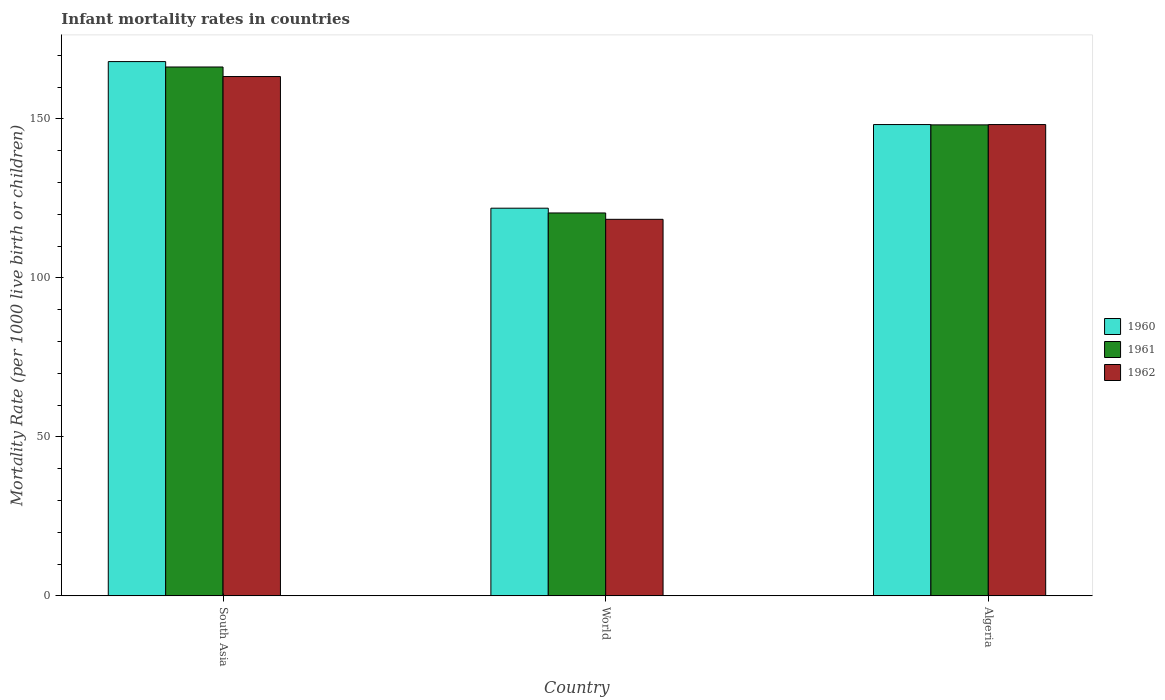How many different coloured bars are there?
Keep it short and to the point. 3. Are the number of bars per tick equal to the number of legend labels?
Your answer should be very brief. Yes. Are the number of bars on each tick of the X-axis equal?
Ensure brevity in your answer.  Yes. How many bars are there on the 2nd tick from the left?
Your answer should be compact. 3. How many bars are there on the 2nd tick from the right?
Give a very brief answer. 3. What is the label of the 2nd group of bars from the left?
Provide a short and direct response. World. What is the infant mortality rate in 1961 in Algeria?
Provide a short and direct response. 148.1. Across all countries, what is the maximum infant mortality rate in 1962?
Your response must be concise. 163.3. Across all countries, what is the minimum infant mortality rate in 1962?
Provide a short and direct response. 118.4. In which country was the infant mortality rate in 1962 maximum?
Offer a very short reply. South Asia. What is the total infant mortality rate in 1962 in the graph?
Provide a succinct answer. 429.9. What is the difference between the infant mortality rate in 1962 in Algeria and that in South Asia?
Provide a short and direct response. -15.1. What is the difference between the infant mortality rate in 1960 in World and the infant mortality rate in 1961 in Algeria?
Ensure brevity in your answer.  -26.2. What is the average infant mortality rate in 1960 per country?
Your answer should be compact. 146.03. In how many countries, is the infant mortality rate in 1962 greater than 100?
Offer a terse response. 3. What is the ratio of the infant mortality rate in 1960 in Algeria to that in South Asia?
Ensure brevity in your answer.  0.88. Is the infant mortality rate in 1961 in Algeria less than that in South Asia?
Give a very brief answer. Yes. Is the difference between the infant mortality rate in 1961 in Algeria and World greater than the difference between the infant mortality rate in 1960 in Algeria and World?
Offer a very short reply. Yes. What is the difference between the highest and the second highest infant mortality rate in 1962?
Your answer should be compact. 15.1. What is the difference between the highest and the lowest infant mortality rate in 1960?
Make the answer very short. 46.1. In how many countries, is the infant mortality rate in 1961 greater than the average infant mortality rate in 1961 taken over all countries?
Your response must be concise. 2. What does the 3rd bar from the right in South Asia represents?
Keep it short and to the point. 1960. Are all the bars in the graph horizontal?
Provide a short and direct response. No. How many countries are there in the graph?
Your response must be concise. 3. What is the difference between two consecutive major ticks on the Y-axis?
Ensure brevity in your answer.  50. Does the graph contain any zero values?
Your answer should be compact. No. Does the graph contain grids?
Provide a short and direct response. No. Where does the legend appear in the graph?
Give a very brief answer. Center right. How many legend labels are there?
Provide a succinct answer. 3. How are the legend labels stacked?
Give a very brief answer. Vertical. What is the title of the graph?
Keep it short and to the point. Infant mortality rates in countries. Does "1994" appear as one of the legend labels in the graph?
Provide a succinct answer. No. What is the label or title of the X-axis?
Keep it short and to the point. Country. What is the label or title of the Y-axis?
Your response must be concise. Mortality Rate (per 1000 live birth or children). What is the Mortality Rate (per 1000 live birth or children) of 1960 in South Asia?
Offer a terse response. 168. What is the Mortality Rate (per 1000 live birth or children) of 1961 in South Asia?
Your answer should be very brief. 166.3. What is the Mortality Rate (per 1000 live birth or children) in 1962 in South Asia?
Provide a short and direct response. 163.3. What is the Mortality Rate (per 1000 live birth or children) of 1960 in World?
Provide a short and direct response. 121.9. What is the Mortality Rate (per 1000 live birth or children) of 1961 in World?
Offer a very short reply. 120.4. What is the Mortality Rate (per 1000 live birth or children) in 1962 in World?
Keep it short and to the point. 118.4. What is the Mortality Rate (per 1000 live birth or children) of 1960 in Algeria?
Keep it short and to the point. 148.2. What is the Mortality Rate (per 1000 live birth or children) in 1961 in Algeria?
Your answer should be compact. 148.1. What is the Mortality Rate (per 1000 live birth or children) of 1962 in Algeria?
Offer a very short reply. 148.2. Across all countries, what is the maximum Mortality Rate (per 1000 live birth or children) in 1960?
Your answer should be compact. 168. Across all countries, what is the maximum Mortality Rate (per 1000 live birth or children) in 1961?
Provide a short and direct response. 166.3. Across all countries, what is the maximum Mortality Rate (per 1000 live birth or children) in 1962?
Your answer should be very brief. 163.3. Across all countries, what is the minimum Mortality Rate (per 1000 live birth or children) in 1960?
Make the answer very short. 121.9. Across all countries, what is the minimum Mortality Rate (per 1000 live birth or children) in 1961?
Provide a succinct answer. 120.4. Across all countries, what is the minimum Mortality Rate (per 1000 live birth or children) of 1962?
Your answer should be compact. 118.4. What is the total Mortality Rate (per 1000 live birth or children) in 1960 in the graph?
Provide a succinct answer. 438.1. What is the total Mortality Rate (per 1000 live birth or children) of 1961 in the graph?
Your response must be concise. 434.8. What is the total Mortality Rate (per 1000 live birth or children) in 1962 in the graph?
Offer a terse response. 429.9. What is the difference between the Mortality Rate (per 1000 live birth or children) in 1960 in South Asia and that in World?
Give a very brief answer. 46.1. What is the difference between the Mortality Rate (per 1000 live birth or children) in 1961 in South Asia and that in World?
Offer a terse response. 45.9. What is the difference between the Mortality Rate (per 1000 live birth or children) of 1962 in South Asia and that in World?
Offer a terse response. 44.9. What is the difference between the Mortality Rate (per 1000 live birth or children) in 1960 in South Asia and that in Algeria?
Give a very brief answer. 19.8. What is the difference between the Mortality Rate (per 1000 live birth or children) of 1961 in South Asia and that in Algeria?
Your answer should be very brief. 18.2. What is the difference between the Mortality Rate (per 1000 live birth or children) in 1962 in South Asia and that in Algeria?
Provide a succinct answer. 15.1. What is the difference between the Mortality Rate (per 1000 live birth or children) in 1960 in World and that in Algeria?
Provide a succinct answer. -26.3. What is the difference between the Mortality Rate (per 1000 live birth or children) in 1961 in World and that in Algeria?
Keep it short and to the point. -27.7. What is the difference between the Mortality Rate (per 1000 live birth or children) of 1962 in World and that in Algeria?
Your answer should be compact. -29.8. What is the difference between the Mortality Rate (per 1000 live birth or children) of 1960 in South Asia and the Mortality Rate (per 1000 live birth or children) of 1961 in World?
Keep it short and to the point. 47.6. What is the difference between the Mortality Rate (per 1000 live birth or children) of 1960 in South Asia and the Mortality Rate (per 1000 live birth or children) of 1962 in World?
Ensure brevity in your answer.  49.6. What is the difference between the Mortality Rate (per 1000 live birth or children) in 1961 in South Asia and the Mortality Rate (per 1000 live birth or children) in 1962 in World?
Offer a very short reply. 47.9. What is the difference between the Mortality Rate (per 1000 live birth or children) of 1960 in South Asia and the Mortality Rate (per 1000 live birth or children) of 1962 in Algeria?
Give a very brief answer. 19.8. What is the difference between the Mortality Rate (per 1000 live birth or children) of 1961 in South Asia and the Mortality Rate (per 1000 live birth or children) of 1962 in Algeria?
Give a very brief answer. 18.1. What is the difference between the Mortality Rate (per 1000 live birth or children) in 1960 in World and the Mortality Rate (per 1000 live birth or children) in 1961 in Algeria?
Your answer should be compact. -26.2. What is the difference between the Mortality Rate (per 1000 live birth or children) in 1960 in World and the Mortality Rate (per 1000 live birth or children) in 1962 in Algeria?
Your answer should be very brief. -26.3. What is the difference between the Mortality Rate (per 1000 live birth or children) of 1961 in World and the Mortality Rate (per 1000 live birth or children) of 1962 in Algeria?
Your answer should be compact. -27.8. What is the average Mortality Rate (per 1000 live birth or children) in 1960 per country?
Your answer should be compact. 146.03. What is the average Mortality Rate (per 1000 live birth or children) in 1961 per country?
Your response must be concise. 144.93. What is the average Mortality Rate (per 1000 live birth or children) in 1962 per country?
Your response must be concise. 143.3. What is the difference between the Mortality Rate (per 1000 live birth or children) of 1960 and Mortality Rate (per 1000 live birth or children) of 1961 in South Asia?
Your answer should be compact. 1.7. What is the difference between the Mortality Rate (per 1000 live birth or children) of 1960 and Mortality Rate (per 1000 live birth or children) of 1961 in World?
Keep it short and to the point. 1.5. What is the difference between the Mortality Rate (per 1000 live birth or children) of 1960 and Mortality Rate (per 1000 live birth or children) of 1962 in World?
Make the answer very short. 3.5. What is the difference between the Mortality Rate (per 1000 live birth or children) in 1961 and Mortality Rate (per 1000 live birth or children) in 1962 in World?
Offer a very short reply. 2. What is the difference between the Mortality Rate (per 1000 live birth or children) in 1960 and Mortality Rate (per 1000 live birth or children) in 1961 in Algeria?
Your answer should be very brief. 0.1. What is the difference between the Mortality Rate (per 1000 live birth or children) of 1960 and Mortality Rate (per 1000 live birth or children) of 1962 in Algeria?
Your response must be concise. 0. What is the difference between the Mortality Rate (per 1000 live birth or children) of 1961 and Mortality Rate (per 1000 live birth or children) of 1962 in Algeria?
Your response must be concise. -0.1. What is the ratio of the Mortality Rate (per 1000 live birth or children) of 1960 in South Asia to that in World?
Your answer should be compact. 1.38. What is the ratio of the Mortality Rate (per 1000 live birth or children) of 1961 in South Asia to that in World?
Your answer should be compact. 1.38. What is the ratio of the Mortality Rate (per 1000 live birth or children) of 1962 in South Asia to that in World?
Your answer should be very brief. 1.38. What is the ratio of the Mortality Rate (per 1000 live birth or children) of 1960 in South Asia to that in Algeria?
Keep it short and to the point. 1.13. What is the ratio of the Mortality Rate (per 1000 live birth or children) of 1961 in South Asia to that in Algeria?
Offer a terse response. 1.12. What is the ratio of the Mortality Rate (per 1000 live birth or children) in 1962 in South Asia to that in Algeria?
Keep it short and to the point. 1.1. What is the ratio of the Mortality Rate (per 1000 live birth or children) in 1960 in World to that in Algeria?
Your answer should be very brief. 0.82. What is the ratio of the Mortality Rate (per 1000 live birth or children) of 1961 in World to that in Algeria?
Offer a terse response. 0.81. What is the ratio of the Mortality Rate (per 1000 live birth or children) of 1962 in World to that in Algeria?
Your answer should be compact. 0.8. What is the difference between the highest and the second highest Mortality Rate (per 1000 live birth or children) of 1960?
Make the answer very short. 19.8. What is the difference between the highest and the second highest Mortality Rate (per 1000 live birth or children) of 1961?
Offer a terse response. 18.2. What is the difference between the highest and the lowest Mortality Rate (per 1000 live birth or children) in 1960?
Make the answer very short. 46.1. What is the difference between the highest and the lowest Mortality Rate (per 1000 live birth or children) of 1961?
Provide a short and direct response. 45.9. What is the difference between the highest and the lowest Mortality Rate (per 1000 live birth or children) of 1962?
Your response must be concise. 44.9. 